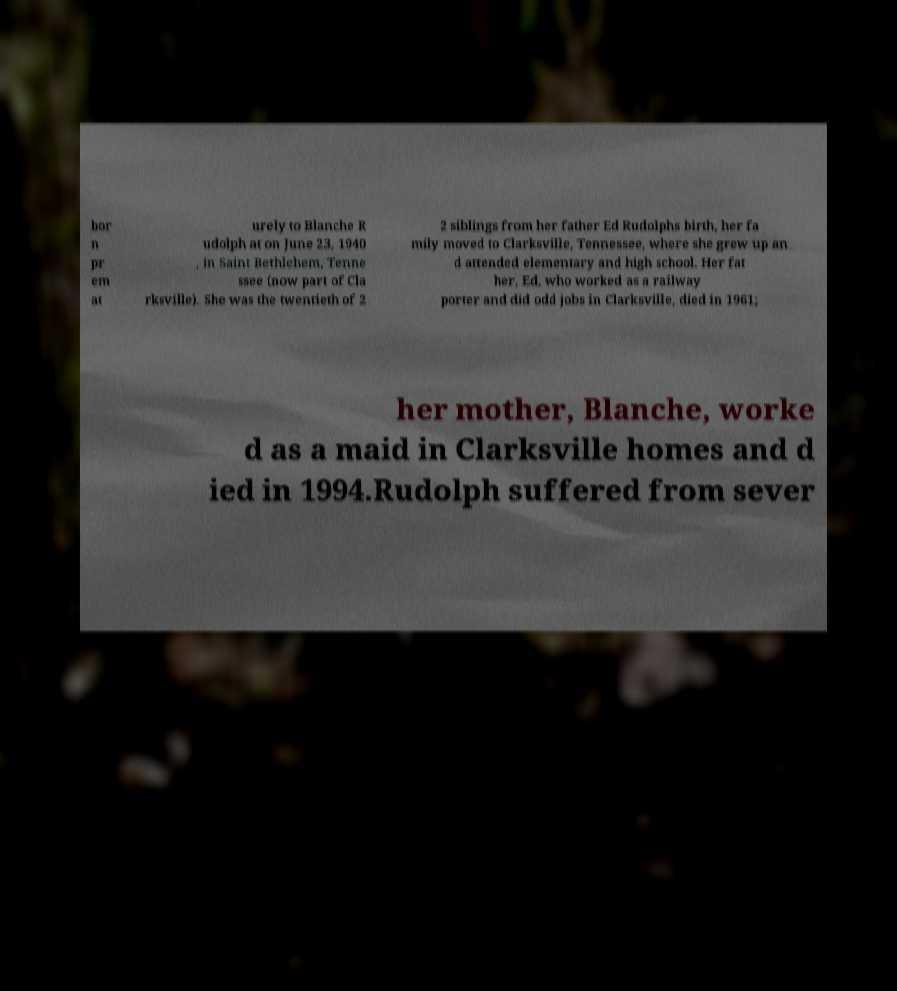Could you assist in decoding the text presented in this image and type it out clearly? bor n pr em at urely to Blanche R udolph at on June 23, 1940 , in Saint Bethlehem, Tenne ssee (now part of Cla rksville). She was the twentieth of 2 2 siblings from her father Ed Rudolphs birth, her fa mily moved to Clarksville, Tennessee, where she grew up an d attended elementary and high school. Her fat her, Ed, who worked as a railway porter and did odd jobs in Clarksville, died in 1961; her mother, Blanche, worke d as a maid in Clarksville homes and d ied in 1994.Rudolph suffered from sever 